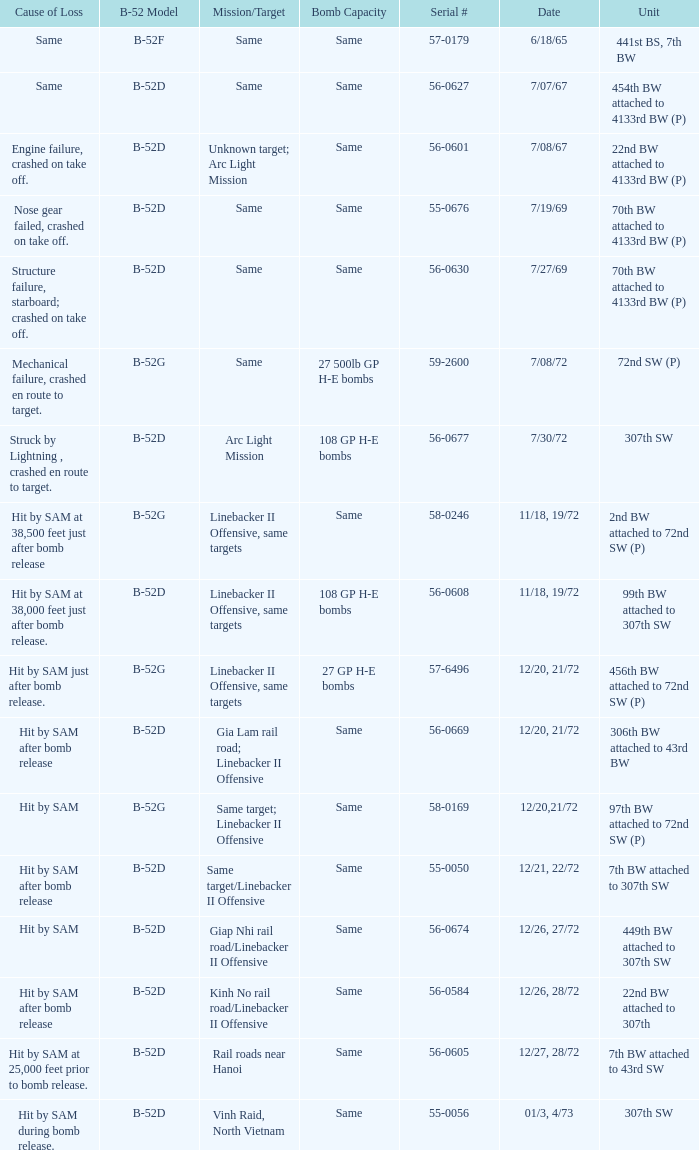When  same target; linebacker ii offensive is the same target what is the unit? 97th BW attached to 72nd SW (P). 